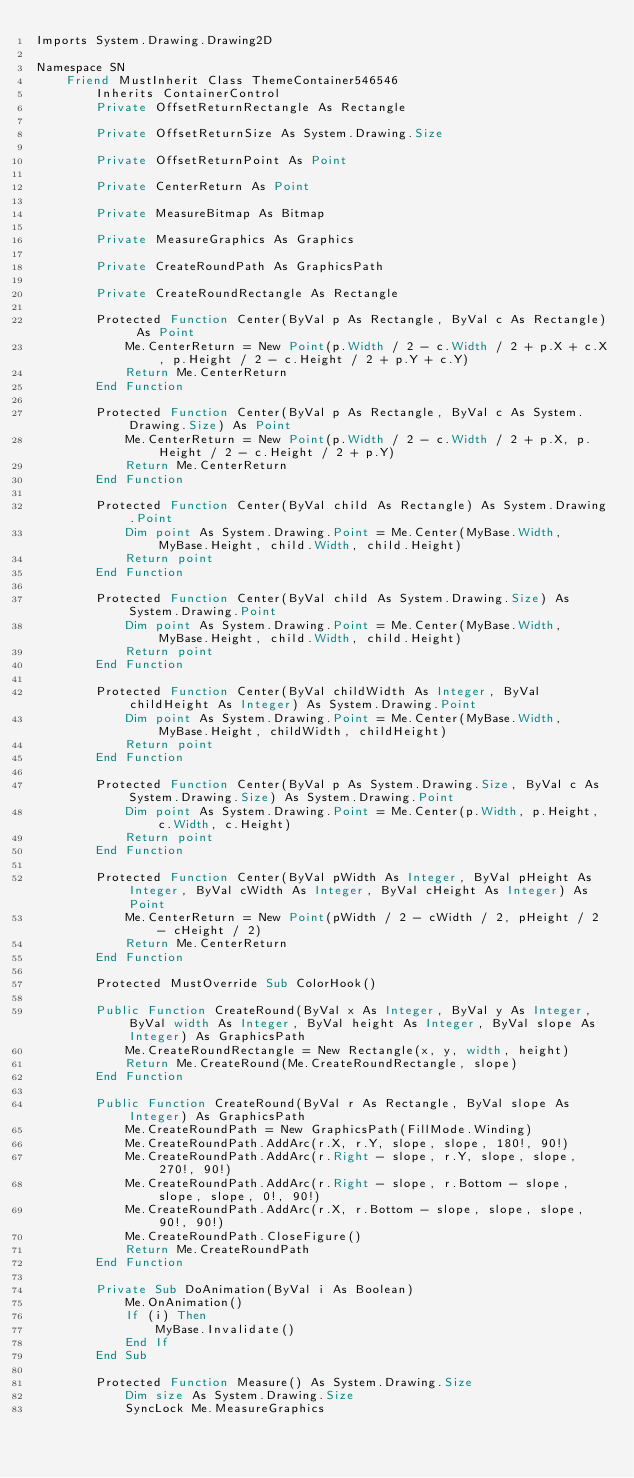<code> <loc_0><loc_0><loc_500><loc_500><_VisualBasic_>Imports System.Drawing.Drawing2D

Namespace SN
	Friend MustInherit Class ThemeContainer546546
		Inherits ContainerControl
		Private OffsetReturnRectangle As Rectangle

		Private OffsetReturnSize As System.Drawing.Size

		Private OffsetReturnPoint As Point

		Private CenterReturn As Point

		Private MeasureBitmap As Bitmap

		Private MeasureGraphics As Graphics

		Private CreateRoundPath As GraphicsPath

		Private CreateRoundRectangle As Rectangle

        Protected Function Center(ByVal p As Rectangle, ByVal c As Rectangle) As Point
            Me.CenterReturn = New Point(p.Width / 2 - c.Width / 2 + p.X + c.X, p.Height / 2 - c.Height / 2 + p.Y + c.Y)
            Return Me.CenterReturn
        End Function

        Protected Function Center(ByVal p As Rectangle, ByVal c As System.Drawing.Size) As Point
			Me.CenterReturn = New Point(p.Width / 2 - c.Width / 2 + p.X, p.Height / 2 - c.Height / 2 + p.Y)
			Return Me.CenterReturn
		End Function

		Protected Function Center(ByVal child As Rectangle) As System.Drawing.Point
			Dim point As System.Drawing.Point = Me.Center(MyBase.Width, MyBase.Height, child.Width, child.Height)
			Return point
		End Function

		Protected Function Center(ByVal child As System.Drawing.Size) As System.Drawing.Point
			Dim point As System.Drawing.Point = Me.Center(MyBase.Width, MyBase.Height, child.Width, child.Height)
			Return point
		End Function

		Protected Function Center(ByVal childWidth As Integer, ByVal childHeight As Integer) As System.Drawing.Point
			Dim point As System.Drawing.Point = Me.Center(MyBase.Width, MyBase.Height, childWidth, childHeight)
			Return point
		End Function

		Protected Function Center(ByVal p As System.Drawing.Size, ByVal c As System.Drawing.Size) As System.Drawing.Point
			Dim point As System.Drawing.Point = Me.Center(p.Width, p.Height, c.Width, c.Height)
			Return point
		End Function

		Protected Function Center(ByVal pWidth As Integer, ByVal pHeight As Integer, ByVal cWidth As Integer, ByVal cHeight As Integer) As Point
			Me.CenterReturn = New Point(pWidth / 2 - cWidth / 2, pHeight / 2 - cHeight / 2)
			Return Me.CenterReturn
		End Function

		Protected MustOverride Sub ColorHook()

		Public Function CreateRound(ByVal x As Integer, ByVal y As Integer, ByVal width As Integer, ByVal height As Integer, ByVal slope As Integer) As GraphicsPath
			Me.CreateRoundRectangle = New Rectangle(x, y, width, height)
			Return Me.CreateRound(Me.CreateRoundRectangle, slope)
		End Function

		Public Function CreateRound(ByVal r As Rectangle, ByVal slope As Integer) As GraphicsPath
			Me.CreateRoundPath = New GraphicsPath(FillMode.Winding)
			Me.CreateRoundPath.AddArc(r.X, r.Y, slope, slope, 180!, 90!)
			Me.CreateRoundPath.AddArc(r.Right - slope, r.Y, slope, slope, 270!, 90!)
			Me.CreateRoundPath.AddArc(r.Right - slope, r.Bottom - slope, slope, slope, 0!, 90!)
			Me.CreateRoundPath.AddArc(r.X, r.Bottom - slope, slope, slope, 90!, 90!)
			Me.CreateRoundPath.CloseFigure()
			Return Me.CreateRoundPath
		End Function

		Private Sub DoAnimation(ByVal i As Boolean)
			Me.OnAnimation()
			If (i) Then
				MyBase.Invalidate()
			End If
		End Sub

		Protected Function Measure() As System.Drawing.Size
			Dim size As System.Drawing.Size
			SyncLock Me.MeasureGraphics</code> 